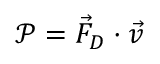<formula> <loc_0><loc_0><loc_500><loc_500>\ m a t h s c r { P } = \vec { F } _ { D } \cdot \vec { v }</formula> 